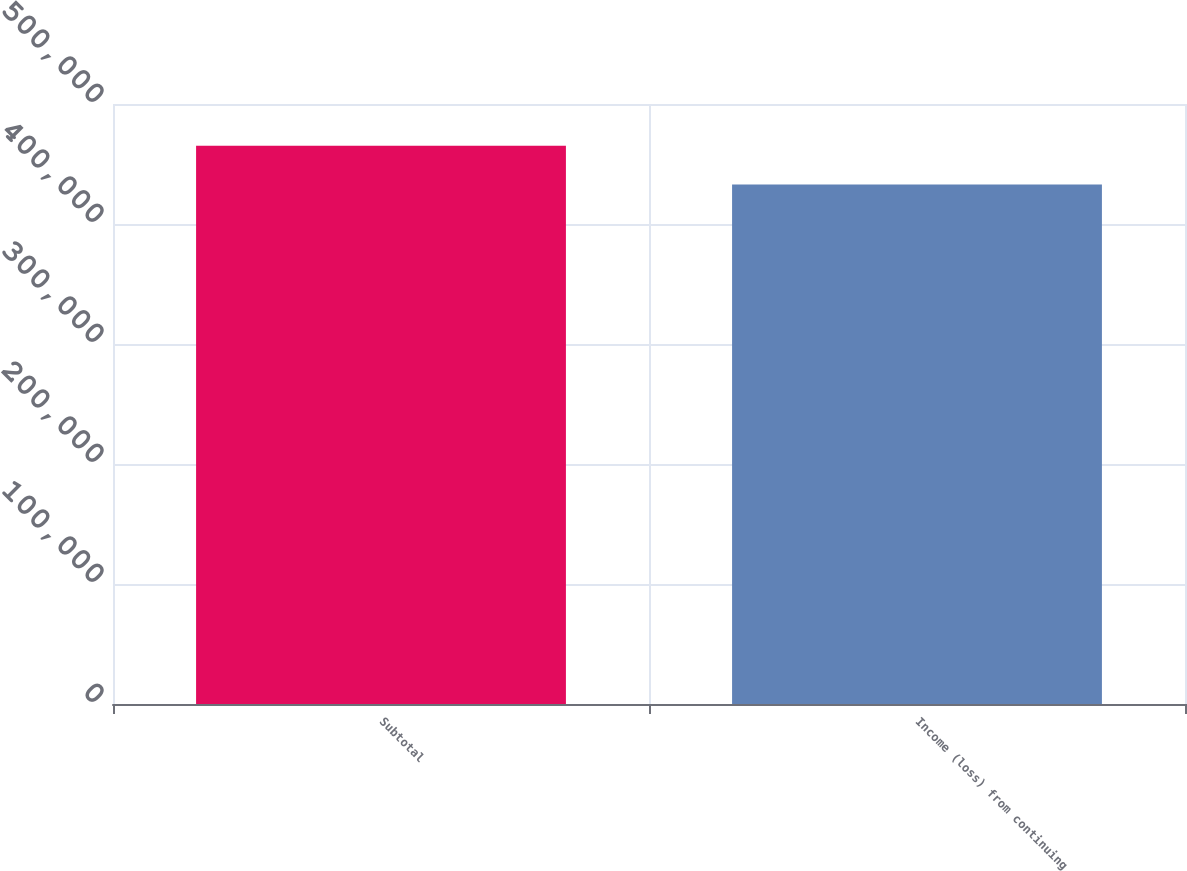<chart> <loc_0><loc_0><loc_500><loc_500><bar_chart><fcel>Subtotal<fcel>Income (loss) from continuing<nl><fcel>465231<fcel>432842<nl></chart> 